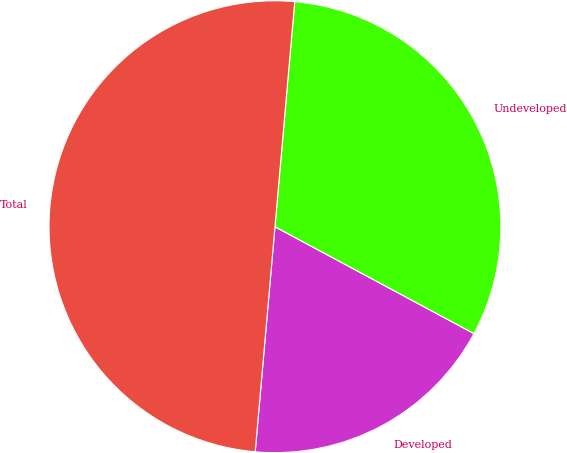<chart> <loc_0><loc_0><loc_500><loc_500><pie_chart><fcel>Developed<fcel>Undeveloped<fcel>Total<nl><fcel>18.55%<fcel>31.45%<fcel>50.0%<nl></chart> 